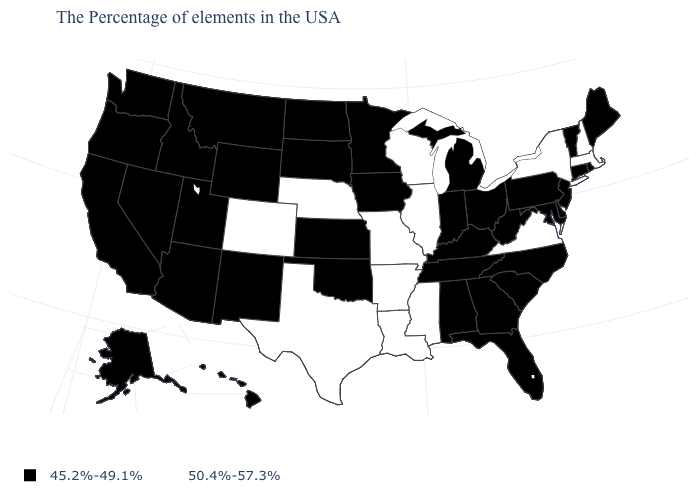What is the value of Massachusetts?
Write a very short answer. 50.4%-57.3%. What is the value of Vermont?
Answer briefly. 45.2%-49.1%. How many symbols are there in the legend?
Concise answer only. 2. Which states hav the highest value in the South?
Concise answer only. Virginia, Mississippi, Louisiana, Arkansas, Texas. What is the value of New Jersey?
Be succinct. 45.2%-49.1%. Does the first symbol in the legend represent the smallest category?
Short answer required. Yes. Name the states that have a value in the range 45.2%-49.1%?
Be succinct. Maine, Rhode Island, Vermont, Connecticut, New Jersey, Delaware, Maryland, Pennsylvania, North Carolina, South Carolina, West Virginia, Ohio, Florida, Georgia, Michigan, Kentucky, Indiana, Alabama, Tennessee, Minnesota, Iowa, Kansas, Oklahoma, South Dakota, North Dakota, Wyoming, New Mexico, Utah, Montana, Arizona, Idaho, Nevada, California, Washington, Oregon, Alaska, Hawaii. Which states have the highest value in the USA?
Give a very brief answer. Massachusetts, New Hampshire, New York, Virginia, Wisconsin, Illinois, Mississippi, Louisiana, Missouri, Arkansas, Nebraska, Texas, Colorado. How many symbols are there in the legend?
Answer briefly. 2. Name the states that have a value in the range 45.2%-49.1%?
Concise answer only. Maine, Rhode Island, Vermont, Connecticut, New Jersey, Delaware, Maryland, Pennsylvania, North Carolina, South Carolina, West Virginia, Ohio, Florida, Georgia, Michigan, Kentucky, Indiana, Alabama, Tennessee, Minnesota, Iowa, Kansas, Oklahoma, South Dakota, North Dakota, Wyoming, New Mexico, Utah, Montana, Arizona, Idaho, Nevada, California, Washington, Oregon, Alaska, Hawaii. Does Tennessee have the same value as Missouri?
Short answer required. No. Is the legend a continuous bar?
Give a very brief answer. No. What is the highest value in the USA?
Be succinct. 50.4%-57.3%. What is the value of Georgia?
Give a very brief answer. 45.2%-49.1%. 